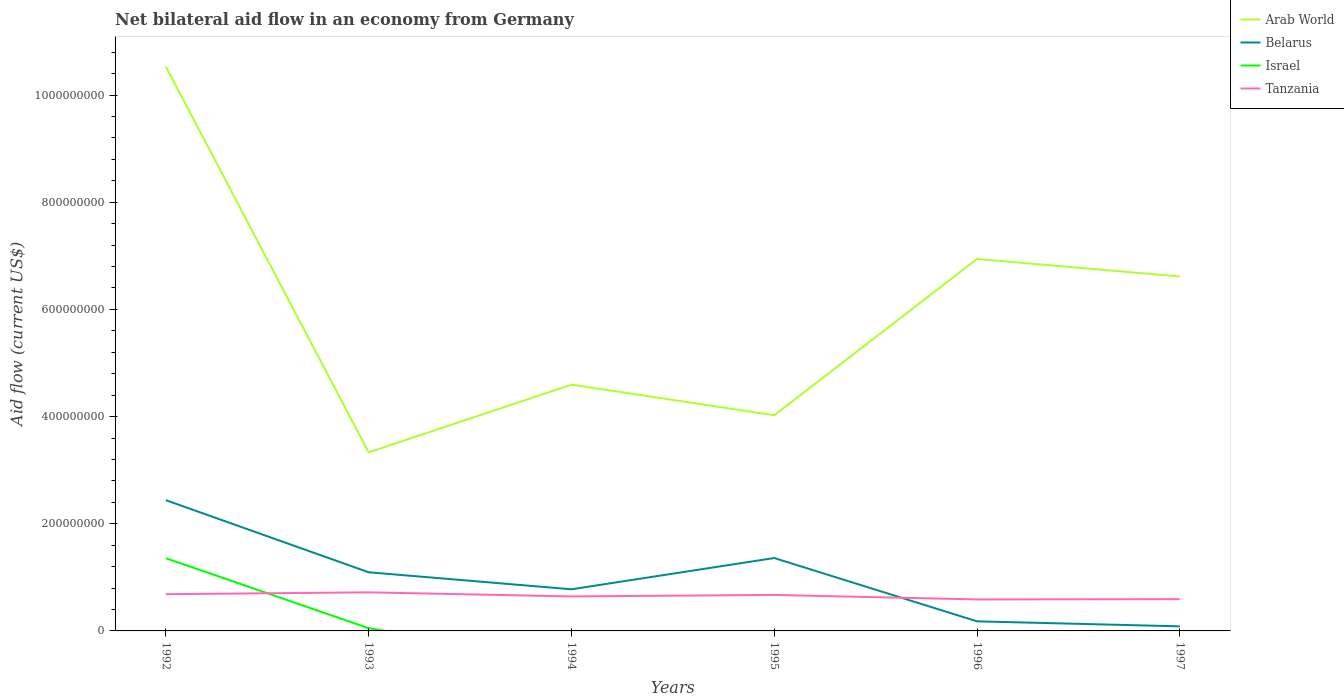How many different coloured lines are there?
Offer a very short reply. 4. Is the number of lines equal to the number of legend labels?
Give a very brief answer. No. What is the total net bilateral aid flow in Tanzania in the graph?
Make the answer very short. 9.77e+06. What is the difference between the highest and the second highest net bilateral aid flow in Israel?
Offer a very short reply. 1.36e+08. What is the difference between the highest and the lowest net bilateral aid flow in Belarus?
Provide a short and direct response. 3. Is the net bilateral aid flow in Belarus strictly greater than the net bilateral aid flow in Israel over the years?
Provide a short and direct response. No. Does the graph contain grids?
Offer a terse response. No. How are the legend labels stacked?
Offer a very short reply. Vertical. What is the title of the graph?
Offer a very short reply. Net bilateral aid flow in an economy from Germany. Does "Tonga" appear as one of the legend labels in the graph?
Provide a succinct answer. No. What is the label or title of the X-axis?
Offer a very short reply. Years. What is the Aid flow (current US$) of Arab World in 1992?
Offer a terse response. 1.05e+09. What is the Aid flow (current US$) in Belarus in 1992?
Your answer should be compact. 2.44e+08. What is the Aid flow (current US$) of Israel in 1992?
Keep it short and to the point. 1.36e+08. What is the Aid flow (current US$) of Tanzania in 1992?
Ensure brevity in your answer.  6.85e+07. What is the Aid flow (current US$) of Arab World in 1993?
Provide a short and direct response. 3.33e+08. What is the Aid flow (current US$) in Belarus in 1993?
Provide a succinct answer. 1.09e+08. What is the Aid flow (current US$) of Israel in 1993?
Give a very brief answer. 5.08e+06. What is the Aid flow (current US$) in Tanzania in 1993?
Make the answer very short. 7.20e+07. What is the Aid flow (current US$) of Arab World in 1994?
Make the answer very short. 4.60e+08. What is the Aid flow (current US$) in Belarus in 1994?
Give a very brief answer. 7.77e+07. What is the Aid flow (current US$) of Israel in 1994?
Your response must be concise. 0. What is the Aid flow (current US$) in Tanzania in 1994?
Your answer should be compact. 6.44e+07. What is the Aid flow (current US$) in Arab World in 1995?
Keep it short and to the point. 4.03e+08. What is the Aid flow (current US$) in Belarus in 1995?
Make the answer very short. 1.36e+08. What is the Aid flow (current US$) of Israel in 1995?
Give a very brief answer. 0. What is the Aid flow (current US$) in Tanzania in 1995?
Offer a terse response. 6.72e+07. What is the Aid flow (current US$) in Arab World in 1996?
Give a very brief answer. 6.94e+08. What is the Aid flow (current US$) of Belarus in 1996?
Make the answer very short. 1.79e+07. What is the Aid flow (current US$) of Israel in 1996?
Provide a short and direct response. 0. What is the Aid flow (current US$) in Tanzania in 1996?
Give a very brief answer. 5.87e+07. What is the Aid flow (current US$) in Arab World in 1997?
Ensure brevity in your answer.  6.61e+08. What is the Aid flow (current US$) of Belarus in 1997?
Offer a very short reply. 8.55e+06. What is the Aid flow (current US$) in Tanzania in 1997?
Ensure brevity in your answer.  5.93e+07. Across all years, what is the maximum Aid flow (current US$) in Arab World?
Your answer should be compact. 1.05e+09. Across all years, what is the maximum Aid flow (current US$) of Belarus?
Keep it short and to the point. 2.44e+08. Across all years, what is the maximum Aid flow (current US$) of Israel?
Your answer should be compact. 1.36e+08. Across all years, what is the maximum Aid flow (current US$) in Tanzania?
Offer a very short reply. 7.20e+07. Across all years, what is the minimum Aid flow (current US$) of Arab World?
Give a very brief answer. 3.33e+08. Across all years, what is the minimum Aid flow (current US$) in Belarus?
Provide a succinct answer. 8.55e+06. Across all years, what is the minimum Aid flow (current US$) in Israel?
Offer a terse response. 0. Across all years, what is the minimum Aid flow (current US$) in Tanzania?
Ensure brevity in your answer.  5.87e+07. What is the total Aid flow (current US$) of Arab World in the graph?
Offer a very short reply. 3.60e+09. What is the total Aid flow (current US$) in Belarus in the graph?
Your answer should be compact. 5.94e+08. What is the total Aid flow (current US$) in Israel in the graph?
Provide a short and direct response. 1.41e+08. What is the total Aid flow (current US$) of Tanzania in the graph?
Ensure brevity in your answer.  3.90e+08. What is the difference between the Aid flow (current US$) in Arab World in 1992 and that in 1993?
Provide a succinct answer. 7.20e+08. What is the difference between the Aid flow (current US$) in Belarus in 1992 and that in 1993?
Your answer should be very brief. 1.35e+08. What is the difference between the Aid flow (current US$) of Israel in 1992 and that in 1993?
Provide a succinct answer. 1.31e+08. What is the difference between the Aid flow (current US$) of Tanzania in 1992 and that in 1993?
Keep it short and to the point. -3.52e+06. What is the difference between the Aid flow (current US$) of Arab World in 1992 and that in 1994?
Ensure brevity in your answer.  5.93e+08. What is the difference between the Aid flow (current US$) of Belarus in 1992 and that in 1994?
Give a very brief answer. 1.66e+08. What is the difference between the Aid flow (current US$) in Tanzania in 1992 and that in 1994?
Ensure brevity in your answer.  4.13e+06. What is the difference between the Aid flow (current US$) of Arab World in 1992 and that in 1995?
Provide a succinct answer. 6.50e+08. What is the difference between the Aid flow (current US$) of Belarus in 1992 and that in 1995?
Provide a short and direct response. 1.08e+08. What is the difference between the Aid flow (current US$) in Tanzania in 1992 and that in 1995?
Make the answer very short. 1.33e+06. What is the difference between the Aid flow (current US$) of Arab World in 1992 and that in 1996?
Offer a terse response. 3.59e+08. What is the difference between the Aid flow (current US$) in Belarus in 1992 and that in 1996?
Give a very brief answer. 2.26e+08. What is the difference between the Aid flow (current US$) in Tanzania in 1992 and that in 1996?
Your answer should be very brief. 9.77e+06. What is the difference between the Aid flow (current US$) of Arab World in 1992 and that in 1997?
Your answer should be very brief. 3.92e+08. What is the difference between the Aid flow (current US$) of Belarus in 1992 and that in 1997?
Offer a terse response. 2.35e+08. What is the difference between the Aid flow (current US$) in Tanzania in 1992 and that in 1997?
Offer a terse response. 9.24e+06. What is the difference between the Aid flow (current US$) of Arab World in 1993 and that in 1994?
Offer a very short reply. -1.26e+08. What is the difference between the Aid flow (current US$) in Belarus in 1993 and that in 1994?
Your answer should be compact. 3.17e+07. What is the difference between the Aid flow (current US$) of Tanzania in 1993 and that in 1994?
Provide a succinct answer. 7.65e+06. What is the difference between the Aid flow (current US$) in Arab World in 1993 and that in 1995?
Ensure brevity in your answer.  -6.92e+07. What is the difference between the Aid flow (current US$) in Belarus in 1993 and that in 1995?
Your answer should be very brief. -2.66e+07. What is the difference between the Aid flow (current US$) of Tanzania in 1993 and that in 1995?
Offer a terse response. 4.85e+06. What is the difference between the Aid flow (current US$) in Arab World in 1993 and that in 1996?
Provide a short and direct response. -3.61e+08. What is the difference between the Aid flow (current US$) in Belarus in 1993 and that in 1996?
Give a very brief answer. 9.16e+07. What is the difference between the Aid flow (current US$) of Tanzania in 1993 and that in 1996?
Ensure brevity in your answer.  1.33e+07. What is the difference between the Aid flow (current US$) in Arab World in 1993 and that in 1997?
Offer a very short reply. -3.28e+08. What is the difference between the Aid flow (current US$) of Belarus in 1993 and that in 1997?
Give a very brief answer. 1.01e+08. What is the difference between the Aid flow (current US$) in Tanzania in 1993 and that in 1997?
Your answer should be compact. 1.28e+07. What is the difference between the Aid flow (current US$) of Arab World in 1994 and that in 1995?
Provide a short and direct response. 5.71e+07. What is the difference between the Aid flow (current US$) in Belarus in 1994 and that in 1995?
Your answer should be very brief. -5.83e+07. What is the difference between the Aid flow (current US$) of Tanzania in 1994 and that in 1995?
Your answer should be compact. -2.80e+06. What is the difference between the Aid flow (current US$) in Arab World in 1994 and that in 1996?
Provide a short and direct response. -2.35e+08. What is the difference between the Aid flow (current US$) in Belarus in 1994 and that in 1996?
Your answer should be compact. 5.98e+07. What is the difference between the Aid flow (current US$) of Tanzania in 1994 and that in 1996?
Provide a succinct answer. 5.64e+06. What is the difference between the Aid flow (current US$) of Arab World in 1994 and that in 1997?
Give a very brief answer. -2.02e+08. What is the difference between the Aid flow (current US$) in Belarus in 1994 and that in 1997?
Offer a terse response. 6.92e+07. What is the difference between the Aid flow (current US$) of Tanzania in 1994 and that in 1997?
Keep it short and to the point. 5.11e+06. What is the difference between the Aid flow (current US$) of Arab World in 1995 and that in 1996?
Keep it short and to the point. -2.92e+08. What is the difference between the Aid flow (current US$) in Belarus in 1995 and that in 1996?
Offer a terse response. 1.18e+08. What is the difference between the Aid flow (current US$) of Tanzania in 1995 and that in 1996?
Offer a terse response. 8.44e+06. What is the difference between the Aid flow (current US$) in Arab World in 1995 and that in 1997?
Offer a very short reply. -2.59e+08. What is the difference between the Aid flow (current US$) of Belarus in 1995 and that in 1997?
Provide a short and direct response. 1.27e+08. What is the difference between the Aid flow (current US$) of Tanzania in 1995 and that in 1997?
Your answer should be very brief. 7.91e+06. What is the difference between the Aid flow (current US$) of Arab World in 1996 and that in 1997?
Offer a terse response. 3.27e+07. What is the difference between the Aid flow (current US$) of Belarus in 1996 and that in 1997?
Make the answer very short. 9.33e+06. What is the difference between the Aid flow (current US$) of Tanzania in 1996 and that in 1997?
Offer a very short reply. -5.30e+05. What is the difference between the Aid flow (current US$) in Arab World in 1992 and the Aid flow (current US$) in Belarus in 1993?
Your answer should be very brief. 9.44e+08. What is the difference between the Aid flow (current US$) in Arab World in 1992 and the Aid flow (current US$) in Israel in 1993?
Your answer should be very brief. 1.05e+09. What is the difference between the Aid flow (current US$) in Arab World in 1992 and the Aid flow (current US$) in Tanzania in 1993?
Offer a very short reply. 9.81e+08. What is the difference between the Aid flow (current US$) in Belarus in 1992 and the Aid flow (current US$) in Israel in 1993?
Keep it short and to the point. 2.39e+08. What is the difference between the Aid flow (current US$) in Belarus in 1992 and the Aid flow (current US$) in Tanzania in 1993?
Keep it short and to the point. 1.72e+08. What is the difference between the Aid flow (current US$) in Israel in 1992 and the Aid flow (current US$) in Tanzania in 1993?
Your answer should be compact. 6.36e+07. What is the difference between the Aid flow (current US$) in Arab World in 1992 and the Aid flow (current US$) in Belarus in 1994?
Keep it short and to the point. 9.75e+08. What is the difference between the Aid flow (current US$) in Arab World in 1992 and the Aid flow (current US$) in Tanzania in 1994?
Make the answer very short. 9.89e+08. What is the difference between the Aid flow (current US$) of Belarus in 1992 and the Aid flow (current US$) of Tanzania in 1994?
Provide a succinct answer. 1.80e+08. What is the difference between the Aid flow (current US$) of Israel in 1992 and the Aid flow (current US$) of Tanzania in 1994?
Provide a short and direct response. 7.13e+07. What is the difference between the Aid flow (current US$) of Arab World in 1992 and the Aid flow (current US$) of Belarus in 1995?
Keep it short and to the point. 9.17e+08. What is the difference between the Aid flow (current US$) in Arab World in 1992 and the Aid flow (current US$) in Tanzania in 1995?
Provide a succinct answer. 9.86e+08. What is the difference between the Aid flow (current US$) in Belarus in 1992 and the Aid flow (current US$) in Tanzania in 1995?
Offer a very short reply. 1.77e+08. What is the difference between the Aid flow (current US$) of Israel in 1992 and the Aid flow (current US$) of Tanzania in 1995?
Ensure brevity in your answer.  6.85e+07. What is the difference between the Aid flow (current US$) of Arab World in 1992 and the Aid flow (current US$) of Belarus in 1996?
Your answer should be compact. 1.04e+09. What is the difference between the Aid flow (current US$) of Arab World in 1992 and the Aid flow (current US$) of Tanzania in 1996?
Ensure brevity in your answer.  9.94e+08. What is the difference between the Aid flow (current US$) in Belarus in 1992 and the Aid flow (current US$) in Tanzania in 1996?
Ensure brevity in your answer.  1.85e+08. What is the difference between the Aid flow (current US$) in Israel in 1992 and the Aid flow (current US$) in Tanzania in 1996?
Keep it short and to the point. 7.69e+07. What is the difference between the Aid flow (current US$) of Arab World in 1992 and the Aid flow (current US$) of Belarus in 1997?
Your answer should be compact. 1.04e+09. What is the difference between the Aid flow (current US$) in Arab World in 1992 and the Aid flow (current US$) in Tanzania in 1997?
Your response must be concise. 9.94e+08. What is the difference between the Aid flow (current US$) of Belarus in 1992 and the Aid flow (current US$) of Tanzania in 1997?
Offer a terse response. 1.85e+08. What is the difference between the Aid flow (current US$) in Israel in 1992 and the Aid flow (current US$) in Tanzania in 1997?
Offer a terse response. 7.64e+07. What is the difference between the Aid flow (current US$) of Arab World in 1993 and the Aid flow (current US$) of Belarus in 1994?
Provide a succinct answer. 2.56e+08. What is the difference between the Aid flow (current US$) in Arab World in 1993 and the Aid flow (current US$) in Tanzania in 1994?
Offer a terse response. 2.69e+08. What is the difference between the Aid flow (current US$) in Belarus in 1993 and the Aid flow (current US$) in Tanzania in 1994?
Offer a terse response. 4.51e+07. What is the difference between the Aid flow (current US$) of Israel in 1993 and the Aid flow (current US$) of Tanzania in 1994?
Keep it short and to the point. -5.93e+07. What is the difference between the Aid flow (current US$) in Arab World in 1993 and the Aid flow (current US$) in Belarus in 1995?
Give a very brief answer. 1.97e+08. What is the difference between the Aid flow (current US$) of Arab World in 1993 and the Aid flow (current US$) of Tanzania in 1995?
Ensure brevity in your answer.  2.66e+08. What is the difference between the Aid flow (current US$) of Belarus in 1993 and the Aid flow (current US$) of Tanzania in 1995?
Your response must be concise. 4.23e+07. What is the difference between the Aid flow (current US$) of Israel in 1993 and the Aid flow (current US$) of Tanzania in 1995?
Ensure brevity in your answer.  -6.21e+07. What is the difference between the Aid flow (current US$) of Arab World in 1993 and the Aid flow (current US$) of Belarus in 1996?
Provide a succinct answer. 3.15e+08. What is the difference between the Aid flow (current US$) in Arab World in 1993 and the Aid flow (current US$) in Tanzania in 1996?
Make the answer very short. 2.75e+08. What is the difference between the Aid flow (current US$) of Belarus in 1993 and the Aid flow (current US$) of Tanzania in 1996?
Offer a very short reply. 5.07e+07. What is the difference between the Aid flow (current US$) of Israel in 1993 and the Aid flow (current US$) of Tanzania in 1996?
Your response must be concise. -5.37e+07. What is the difference between the Aid flow (current US$) of Arab World in 1993 and the Aid flow (current US$) of Belarus in 1997?
Keep it short and to the point. 3.25e+08. What is the difference between the Aid flow (current US$) of Arab World in 1993 and the Aid flow (current US$) of Tanzania in 1997?
Offer a terse response. 2.74e+08. What is the difference between the Aid flow (current US$) in Belarus in 1993 and the Aid flow (current US$) in Tanzania in 1997?
Your answer should be very brief. 5.02e+07. What is the difference between the Aid flow (current US$) of Israel in 1993 and the Aid flow (current US$) of Tanzania in 1997?
Your response must be concise. -5.42e+07. What is the difference between the Aid flow (current US$) of Arab World in 1994 and the Aid flow (current US$) of Belarus in 1995?
Offer a very short reply. 3.24e+08. What is the difference between the Aid flow (current US$) in Arab World in 1994 and the Aid flow (current US$) in Tanzania in 1995?
Offer a very short reply. 3.92e+08. What is the difference between the Aid flow (current US$) in Belarus in 1994 and the Aid flow (current US$) in Tanzania in 1995?
Make the answer very short. 1.05e+07. What is the difference between the Aid flow (current US$) of Arab World in 1994 and the Aid flow (current US$) of Belarus in 1996?
Offer a terse response. 4.42e+08. What is the difference between the Aid flow (current US$) of Arab World in 1994 and the Aid flow (current US$) of Tanzania in 1996?
Your answer should be very brief. 4.01e+08. What is the difference between the Aid flow (current US$) of Belarus in 1994 and the Aid flow (current US$) of Tanzania in 1996?
Your response must be concise. 1.90e+07. What is the difference between the Aid flow (current US$) in Arab World in 1994 and the Aid flow (current US$) in Belarus in 1997?
Keep it short and to the point. 4.51e+08. What is the difference between the Aid flow (current US$) of Arab World in 1994 and the Aid flow (current US$) of Tanzania in 1997?
Your answer should be very brief. 4.00e+08. What is the difference between the Aid flow (current US$) of Belarus in 1994 and the Aid flow (current US$) of Tanzania in 1997?
Your answer should be very brief. 1.84e+07. What is the difference between the Aid flow (current US$) of Arab World in 1995 and the Aid flow (current US$) of Belarus in 1996?
Keep it short and to the point. 3.85e+08. What is the difference between the Aid flow (current US$) of Arab World in 1995 and the Aid flow (current US$) of Tanzania in 1996?
Your response must be concise. 3.44e+08. What is the difference between the Aid flow (current US$) in Belarus in 1995 and the Aid flow (current US$) in Tanzania in 1996?
Give a very brief answer. 7.73e+07. What is the difference between the Aid flow (current US$) of Arab World in 1995 and the Aid flow (current US$) of Belarus in 1997?
Give a very brief answer. 3.94e+08. What is the difference between the Aid flow (current US$) of Arab World in 1995 and the Aid flow (current US$) of Tanzania in 1997?
Your answer should be compact. 3.43e+08. What is the difference between the Aid flow (current US$) of Belarus in 1995 and the Aid flow (current US$) of Tanzania in 1997?
Give a very brief answer. 7.68e+07. What is the difference between the Aid flow (current US$) in Arab World in 1996 and the Aid flow (current US$) in Belarus in 1997?
Make the answer very short. 6.86e+08. What is the difference between the Aid flow (current US$) of Arab World in 1996 and the Aid flow (current US$) of Tanzania in 1997?
Give a very brief answer. 6.35e+08. What is the difference between the Aid flow (current US$) of Belarus in 1996 and the Aid flow (current US$) of Tanzania in 1997?
Give a very brief answer. -4.14e+07. What is the average Aid flow (current US$) in Arab World per year?
Your answer should be compact. 6.01e+08. What is the average Aid flow (current US$) of Belarus per year?
Your response must be concise. 9.89e+07. What is the average Aid flow (current US$) of Israel per year?
Keep it short and to the point. 2.35e+07. What is the average Aid flow (current US$) in Tanzania per year?
Provide a succinct answer. 6.50e+07. In the year 1992, what is the difference between the Aid flow (current US$) in Arab World and Aid flow (current US$) in Belarus?
Keep it short and to the point. 8.09e+08. In the year 1992, what is the difference between the Aid flow (current US$) in Arab World and Aid flow (current US$) in Israel?
Your answer should be compact. 9.17e+08. In the year 1992, what is the difference between the Aid flow (current US$) in Arab World and Aid flow (current US$) in Tanzania?
Keep it short and to the point. 9.84e+08. In the year 1992, what is the difference between the Aid flow (current US$) of Belarus and Aid flow (current US$) of Israel?
Offer a terse response. 1.08e+08. In the year 1992, what is the difference between the Aid flow (current US$) in Belarus and Aid flow (current US$) in Tanzania?
Your answer should be compact. 1.75e+08. In the year 1992, what is the difference between the Aid flow (current US$) of Israel and Aid flow (current US$) of Tanzania?
Provide a short and direct response. 6.72e+07. In the year 1993, what is the difference between the Aid flow (current US$) of Arab World and Aid flow (current US$) of Belarus?
Offer a very short reply. 2.24e+08. In the year 1993, what is the difference between the Aid flow (current US$) of Arab World and Aid flow (current US$) of Israel?
Offer a terse response. 3.28e+08. In the year 1993, what is the difference between the Aid flow (current US$) in Arab World and Aid flow (current US$) in Tanzania?
Make the answer very short. 2.61e+08. In the year 1993, what is the difference between the Aid flow (current US$) in Belarus and Aid flow (current US$) in Israel?
Provide a succinct answer. 1.04e+08. In the year 1993, what is the difference between the Aid flow (current US$) in Belarus and Aid flow (current US$) in Tanzania?
Provide a short and direct response. 3.74e+07. In the year 1993, what is the difference between the Aid flow (current US$) of Israel and Aid flow (current US$) of Tanzania?
Ensure brevity in your answer.  -6.70e+07. In the year 1994, what is the difference between the Aid flow (current US$) of Arab World and Aid flow (current US$) of Belarus?
Provide a short and direct response. 3.82e+08. In the year 1994, what is the difference between the Aid flow (current US$) of Arab World and Aid flow (current US$) of Tanzania?
Give a very brief answer. 3.95e+08. In the year 1994, what is the difference between the Aid flow (current US$) in Belarus and Aid flow (current US$) in Tanzania?
Your answer should be compact. 1.33e+07. In the year 1995, what is the difference between the Aid flow (current US$) of Arab World and Aid flow (current US$) of Belarus?
Your answer should be very brief. 2.66e+08. In the year 1995, what is the difference between the Aid flow (current US$) in Arab World and Aid flow (current US$) in Tanzania?
Keep it short and to the point. 3.35e+08. In the year 1995, what is the difference between the Aid flow (current US$) of Belarus and Aid flow (current US$) of Tanzania?
Your response must be concise. 6.88e+07. In the year 1996, what is the difference between the Aid flow (current US$) in Arab World and Aid flow (current US$) in Belarus?
Your answer should be very brief. 6.76e+08. In the year 1996, what is the difference between the Aid flow (current US$) in Arab World and Aid flow (current US$) in Tanzania?
Make the answer very short. 6.35e+08. In the year 1996, what is the difference between the Aid flow (current US$) of Belarus and Aid flow (current US$) of Tanzania?
Your answer should be very brief. -4.09e+07. In the year 1997, what is the difference between the Aid flow (current US$) in Arab World and Aid flow (current US$) in Belarus?
Your response must be concise. 6.53e+08. In the year 1997, what is the difference between the Aid flow (current US$) in Arab World and Aid flow (current US$) in Tanzania?
Provide a succinct answer. 6.02e+08. In the year 1997, what is the difference between the Aid flow (current US$) in Belarus and Aid flow (current US$) in Tanzania?
Give a very brief answer. -5.07e+07. What is the ratio of the Aid flow (current US$) of Arab World in 1992 to that in 1993?
Offer a very short reply. 3.16. What is the ratio of the Aid flow (current US$) in Belarus in 1992 to that in 1993?
Ensure brevity in your answer.  2.23. What is the ratio of the Aid flow (current US$) in Israel in 1992 to that in 1993?
Give a very brief answer. 26.71. What is the ratio of the Aid flow (current US$) of Tanzania in 1992 to that in 1993?
Provide a succinct answer. 0.95. What is the ratio of the Aid flow (current US$) in Arab World in 1992 to that in 1994?
Offer a terse response. 2.29. What is the ratio of the Aid flow (current US$) of Belarus in 1992 to that in 1994?
Your response must be concise. 3.14. What is the ratio of the Aid flow (current US$) of Tanzania in 1992 to that in 1994?
Make the answer very short. 1.06. What is the ratio of the Aid flow (current US$) of Arab World in 1992 to that in 1995?
Your response must be concise. 2.62. What is the ratio of the Aid flow (current US$) in Belarus in 1992 to that in 1995?
Provide a succinct answer. 1.79. What is the ratio of the Aid flow (current US$) in Tanzania in 1992 to that in 1995?
Give a very brief answer. 1.02. What is the ratio of the Aid flow (current US$) in Arab World in 1992 to that in 1996?
Keep it short and to the point. 1.52. What is the ratio of the Aid flow (current US$) of Belarus in 1992 to that in 1996?
Your answer should be compact. 13.65. What is the ratio of the Aid flow (current US$) in Tanzania in 1992 to that in 1996?
Ensure brevity in your answer.  1.17. What is the ratio of the Aid flow (current US$) of Arab World in 1992 to that in 1997?
Provide a succinct answer. 1.59. What is the ratio of the Aid flow (current US$) of Belarus in 1992 to that in 1997?
Offer a terse response. 28.54. What is the ratio of the Aid flow (current US$) of Tanzania in 1992 to that in 1997?
Provide a short and direct response. 1.16. What is the ratio of the Aid flow (current US$) of Arab World in 1993 to that in 1994?
Provide a short and direct response. 0.73. What is the ratio of the Aid flow (current US$) of Belarus in 1993 to that in 1994?
Provide a short and direct response. 1.41. What is the ratio of the Aid flow (current US$) in Tanzania in 1993 to that in 1994?
Keep it short and to the point. 1.12. What is the ratio of the Aid flow (current US$) in Arab World in 1993 to that in 1995?
Offer a terse response. 0.83. What is the ratio of the Aid flow (current US$) of Belarus in 1993 to that in 1995?
Provide a succinct answer. 0.8. What is the ratio of the Aid flow (current US$) of Tanzania in 1993 to that in 1995?
Offer a very short reply. 1.07. What is the ratio of the Aid flow (current US$) of Arab World in 1993 to that in 1996?
Keep it short and to the point. 0.48. What is the ratio of the Aid flow (current US$) in Belarus in 1993 to that in 1996?
Your answer should be compact. 6.12. What is the ratio of the Aid flow (current US$) in Tanzania in 1993 to that in 1996?
Your answer should be compact. 1.23. What is the ratio of the Aid flow (current US$) in Arab World in 1993 to that in 1997?
Provide a short and direct response. 0.5. What is the ratio of the Aid flow (current US$) of Belarus in 1993 to that in 1997?
Offer a terse response. 12.8. What is the ratio of the Aid flow (current US$) of Tanzania in 1993 to that in 1997?
Provide a succinct answer. 1.22. What is the ratio of the Aid flow (current US$) of Arab World in 1994 to that in 1995?
Your answer should be very brief. 1.14. What is the ratio of the Aid flow (current US$) of Belarus in 1994 to that in 1995?
Make the answer very short. 0.57. What is the ratio of the Aid flow (current US$) in Arab World in 1994 to that in 1996?
Ensure brevity in your answer.  0.66. What is the ratio of the Aid flow (current US$) of Belarus in 1994 to that in 1996?
Provide a succinct answer. 4.35. What is the ratio of the Aid flow (current US$) of Tanzania in 1994 to that in 1996?
Your answer should be compact. 1.1. What is the ratio of the Aid flow (current US$) of Arab World in 1994 to that in 1997?
Provide a succinct answer. 0.69. What is the ratio of the Aid flow (current US$) of Belarus in 1994 to that in 1997?
Offer a very short reply. 9.09. What is the ratio of the Aid flow (current US$) in Tanzania in 1994 to that in 1997?
Make the answer very short. 1.09. What is the ratio of the Aid flow (current US$) of Arab World in 1995 to that in 1996?
Offer a very short reply. 0.58. What is the ratio of the Aid flow (current US$) in Belarus in 1995 to that in 1996?
Provide a succinct answer. 7.61. What is the ratio of the Aid flow (current US$) of Tanzania in 1995 to that in 1996?
Your answer should be compact. 1.14. What is the ratio of the Aid flow (current US$) in Arab World in 1995 to that in 1997?
Offer a very short reply. 0.61. What is the ratio of the Aid flow (current US$) in Belarus in 1995 to that in 1997?
Your answer should be compact. 15.91. What is the ratio of the Aid flow (current US$) of Tanzania in 1995 to that in 1997?
Ensure brevity in your answer.  1.13. What is the ratio of the Aid flow (current US$) in Arab World in 1996 to that in 1997?
Ensure brevity in your answer.  1.05. What is the ratio of the Aid flow (current US$) of Belarus in 1996 to that in 1997?
Make the answer very short. 2.09. What is the difference between the highest and the second highest Aid flow (current US$) of Arab World?
Your answer should be compact. 3.59e+08. What is the difference between the highest and the second highest Aid flow (current US$) in Belarus?
Keep it short and to the point. 1.08e+08. What is the difference between the highest and the second highest Aid flow (current US$) of Tanzania?
Give a very brief answer. 3.52e+06. What is the difference between the highest and the lowest Aid flow (current US$) of Arab World?
Make the answer very short. 7.20e+08. What is the difference between the highest and the lowest Aid flow (current US$) in Belarus?
Keep it short and to the point. 2.35e+08. What is the difference between the highest and the lowest Aid flow (current US$) in Israel?
Provide a succinct answer. 1.36e+08. What is the difference between the highest and the lowest Aid flow (current US$) in Tanzania?
Offer a very short reply. 1.33e+07. 